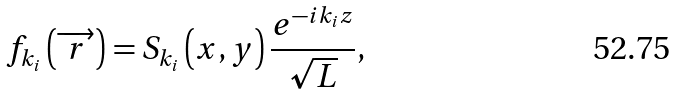<formula> <loc_0><loc_0><loc_500><loc_500>f _ { k _ { i } } \left ( \overrightarrow { r } \right ) = S _ { k _ { i } } \left ( x , y \right ) \frac { e ^ { - i k _ { i } z } } { \sqrt { L } } ,</formula> 